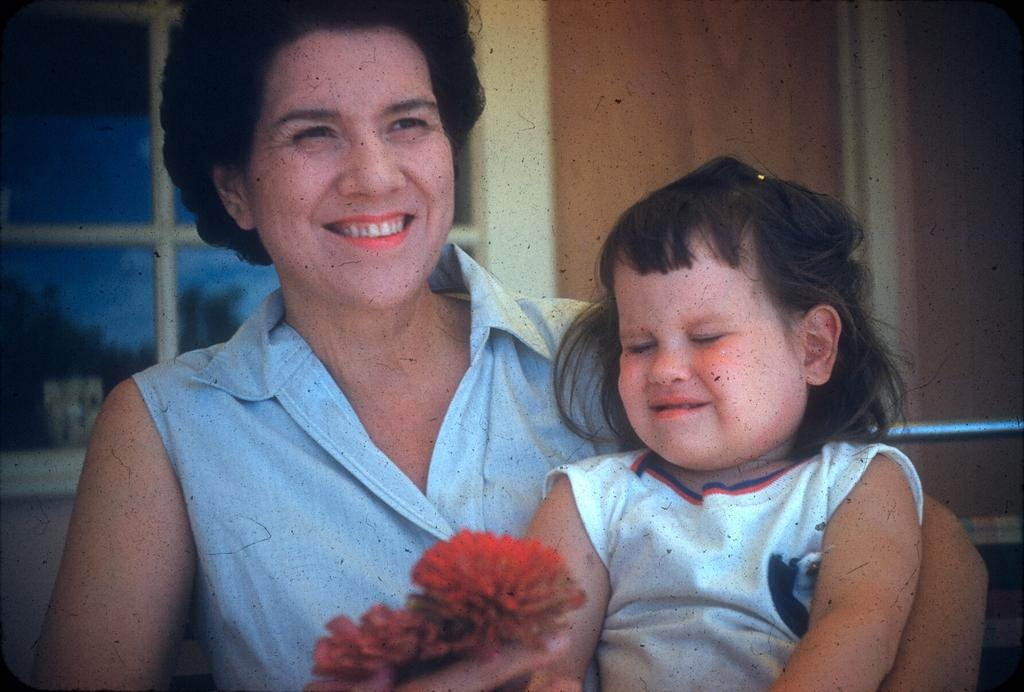Who is the main subject in the image? There is a lady in the center of the image. What is the lady holding in the image? The lady is holding a kid and flowers. What can be seen in the background of the image? There is a wall, a window, glass, and trees in the background of the image. What type of grain is visible in the image? There is no grain present in the image. How does the lady's knee look in the image? The lady's knee is not visible in the image, as she is holding a kid and flowers. 